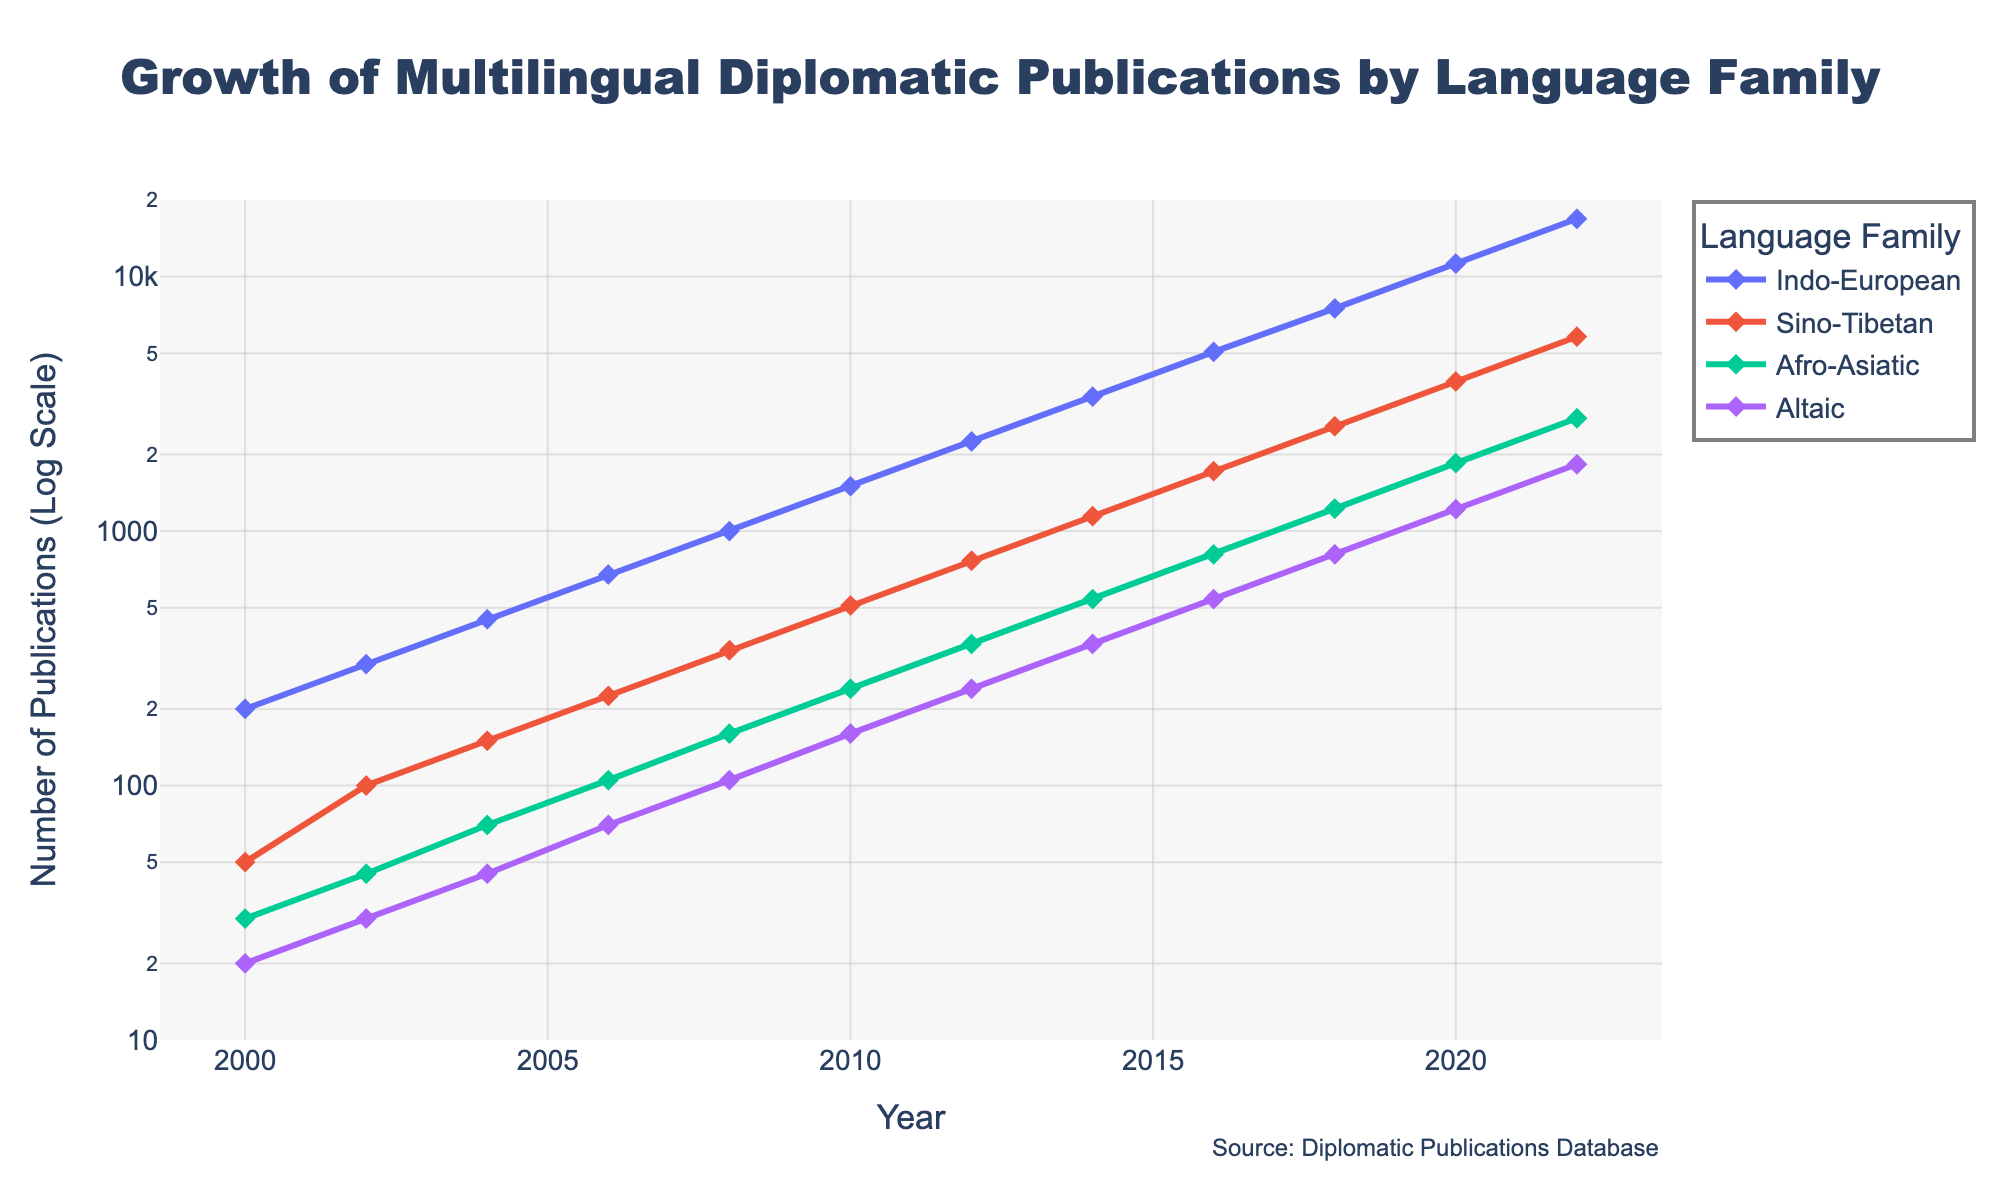What is the title of the figure? The title is located at the top center of the figure and denotes the main topic of the visualization.
Answer: Growth of Multilingual Diplomatic Publications by Language Family What does the y-axis represent? The y-axis represents the number of publications, and it is set on a logarithmic scale, which helps visualize exponential growth patterns.
Answer: Number of Publications (Log Scale) Which language family shows the highest number of publications in 2022? By observing the data points for the year 2022, Indo-European has the highest value among all language families.
Answer: Indo-European How did the number of multilingual diplomatic publications for the Sino-Tibetan family grow from 2000 to 2022? To find the growth, we look at the Sino-Tibetan points in 2000 and 2022 and compare. It grows from 50 publications in 2000 to 5805 in 2022.
Answer: From 50 to 5805 Among the language families, which one had the least growth rate of publications over the years? Comparing all families' lines on the plot, the Altaic family has the smallest number of publications throughout the years.
Answer: Altaic What was the growth rate difference between Indo-European and Afro-Asiatic from 2014 to 2022? From the plot, Indo-European grew from 3375 to 16875, and Afro-Asiatic grew from 540 to 2775. The growth rate difference is (16875 - 3375) - (2775 - 540).
Answer: 11430 In which year did Indo-European publications exceed 1000? By tracing the Indo-European line on the plot, it exceeded 1000 publications in 2008.
Answer: 2008 Which language family had the steepest increase between 2018 and 2020? Observing the slope of lines between 2018 and 2020, Indo-European shows the steepest increase as its line rises the most sharply in this period.
Answer: Indo-European How does the growth pattern of Afro-Asiatic compare to Sino-Tibetan over the years? By comparing the slopes of Afro-Asiatic and Sino-Tibetan lines throughout the plot, Sino-Tibetan shows a consistently steeper rise, indicating a faster growth rate.
Answer: Sino-Tibetan 